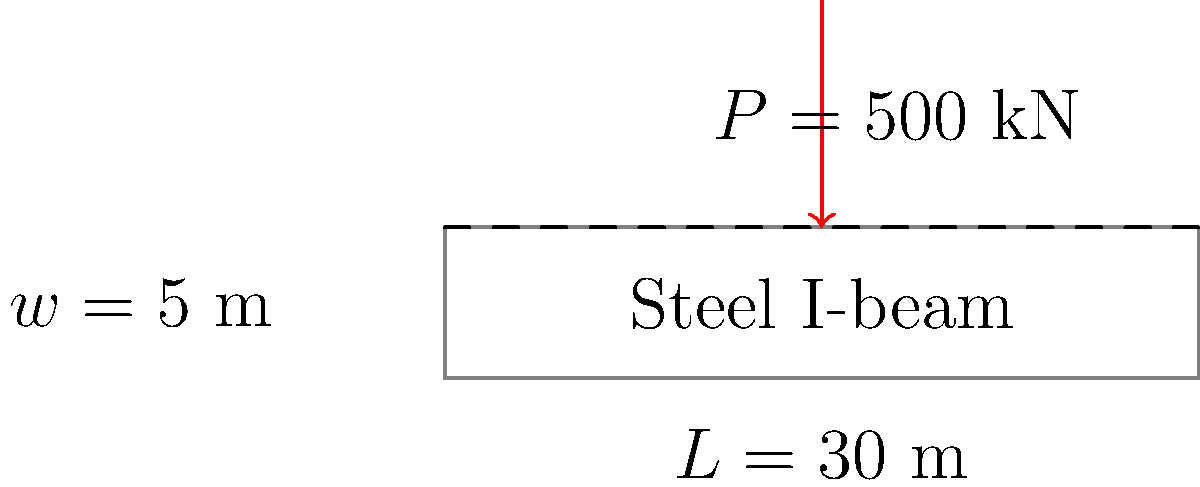A steel I-beam bridge spanning a river in the Australian Outback needs to be assessed for its load-bearing capacity. The bridge has a length of 30 meters and a width of 5 meters. It's designed to support a concentrated load of 500 kN at its midpoint. Given that the allowable bending stress for the steel used is 165 MPa and the section modulus of the I-beam is $2.5 \times 10^6$ mm³, determine if the bridge can safely support the load. What is the maximum bending moment in kN⋅m? Let's approach this step-by-step:

1) First, we need to calculate the maximum bending moment. For a simply supported beam with a concentrated load at the center:

   $$M_{max} = \frac{PL}{4}$$

   Where $P$ is the concentrated load and $L$ is the length of the bridge.

2) Substituting the values:
   
   $$M_{max} = \frac{500 \text{ kN} \times 30 \text{ m}}{4} = 3750 \text{ kN⋅m}$$

3) To check if the bridge can support this load, we need to compare the induced stress with the allowable stress.

4) The bending stress is given by:

   $$\sigma = \frac{M}{S}$$

   Where $M$ is the bending moment and $S$ is the section modulus.

5) Converting the moment to N⋅mm:

   $$3750 \text{ kN⋅m} = 3.75 \times 10^9 \text{ N⋅mm}$$

6) Calculating the induced stress:

   $$\sigma = \frac{3.75 \times 10^9 \text{ N⋅mm}}{2.5 \times 10^6 \text{ mm}^3} = 1500 \text{ MPa}$$

7) Comparing with the allowable stress:

   $1500 \text{ MPa} > 165 \text{ MPa}$

Therefore, the induced stress exceeds the allowable stress, and the bridge cannot safely support this load as designed.
Answer: 3750 kN⋅m; bridge unsafe 